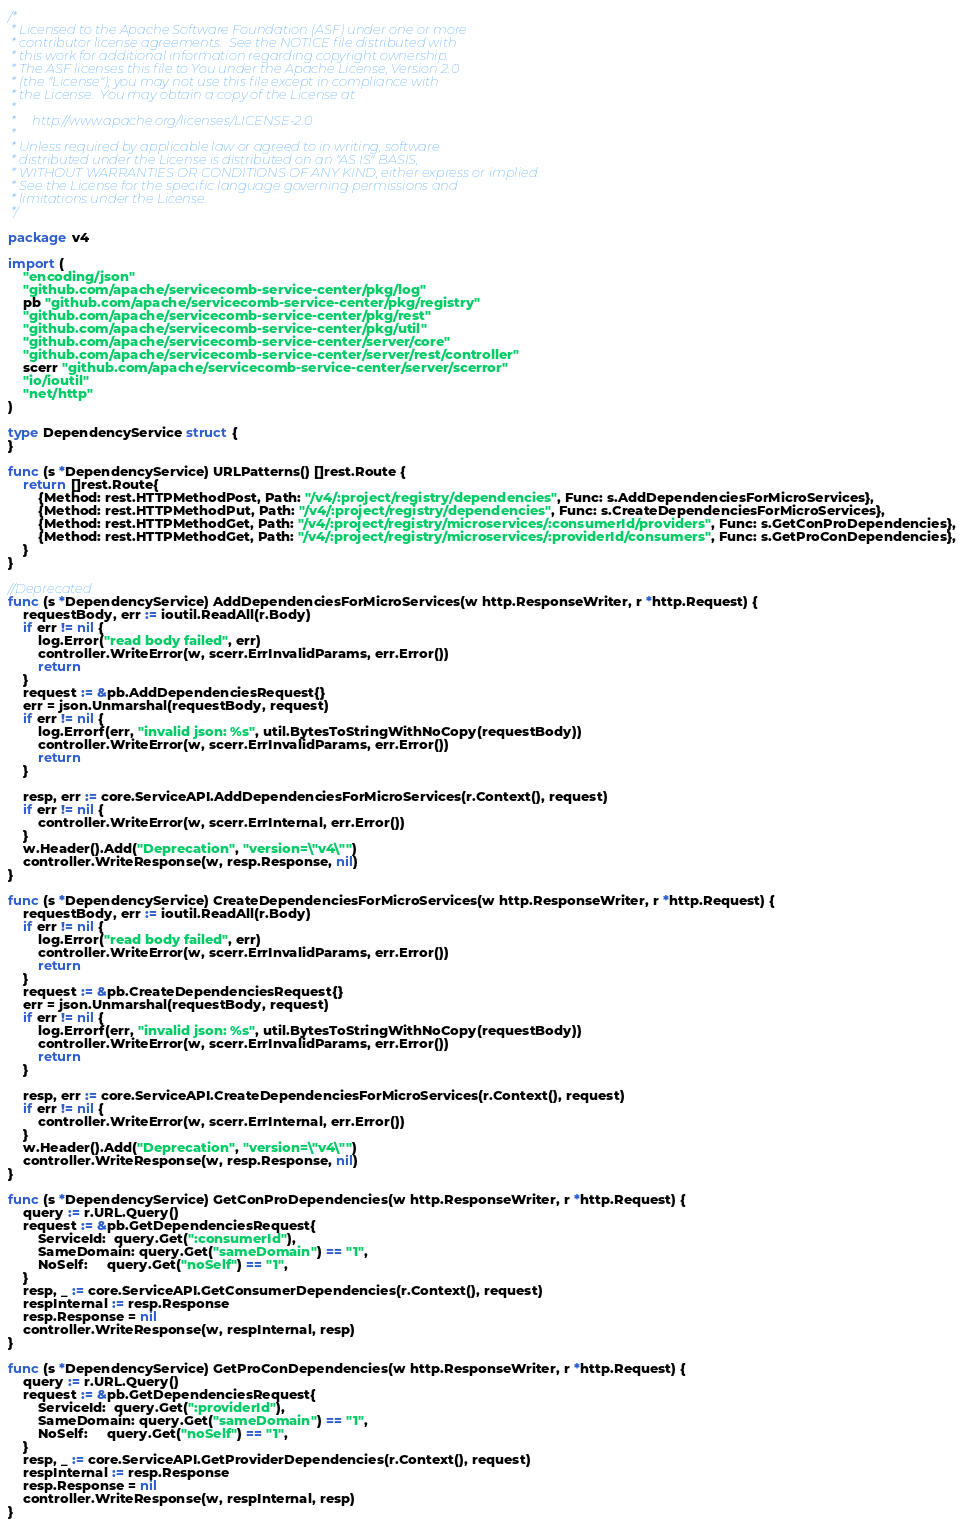Convert code to text. <code><loc_0><loc_0><loc_500><loc_500><_Go_>/*
 * Licensed to the Apache Software Foundation (ASF) under one or more
 * contributor license agreements.  See the NOTICE file distributed with
 * this work for additional information regarding copyright ownership.
 * The ASF licenses this file to You under the Apache License, Version 2.0
 * (the "License"); you may not use this file except in compliance with
 * the License.  You may obtain a copy of the License at
 *
 *     http://www.apache.org/licenses/LICENSE-2.0
 *
 * Unless required by applicable law or agreed to in writing, software
 * distributed under the License is distributed on an "AS IS" BASIS,
 * WITHOUT WARRANTIES OR CONDITIONS OF ANY KIND, either express or implied.
 * See the License for the specific language governing permissions and
 * limitations under the License.
 */

package v4

import (
	"encoding/json"
	"github.com/apache/servicecomb-service-center/pkg/log"
	pb "github.com/apache/servicecomb-service-center/pkg/registry"
	"github.com/apache/servicecomb-service-center/pkg/rest"
	"github.com/apache/servicecomb-service-center/pkg/util"
	"github.com/apache/servicecomb-service-center/server/core"
	"github.com/apache/servicecomb-service-center/server/rest/controller"
	scerr "github.com/apache/servicecomb-service-center/server/scerror"
	"io/ioutil"
	"net/http"
)

type DependencyService struct {
}

func (s *DependencyService) URLPatterns() []rest.Route {
	return []rest.Route{
		{Method: rest.HTTPMethodPost, Path: "/v4/:project/registry/dependencies", Func: s.AddDependenciesForMicroServices},
		{Method: rest.HTTPMethodPut, Path: "/v4/:project/registry/dependencies", Func: s.CreateDependenciesForMicroServices},
		{Method: rest.HTTPMethodGet, Path: "/v4/:project/registry/microservices/:consumerId/providers", Func: s.GetConProDependencies},
		{Method: rest.HTTPMethodGet, Path: "/v4/:project/registry/microservices/:providerId/consumers", Func: s.GetProConDependencies},
	}
}

//Deprecated
func (s *DependencyService) AddDependenciesForMicroServices(w http.ResponseWriter, r *http.Request) {
	requestBody, err := ioutil.ReadAll(r.Body)
	if err != nil {
		log.Error("read body failed", err)
		controller.WriteError(w, scerr.ErrInvalidParams, err.Error())
		return
	}
	request := &pb.AddDependenciesRequest{}
	err = json.Unmarshal(requestBody, request)
	if err != nil {
		log.Errorf(err, "invalid json: %s", util.BytesToStringWithNoCopy(requestBody))
		controller.WriteError(w, scerr.ErrInvalidParams, err.Error())
		return
	}

	resp, err := core.ServiceAPI.AddDependenciesForMicroServices(r.Context(), request)
	if err != nil {
		controller.WriteError(w, scerr.ErrInternal, err.Error())
	}
	w.Header().Add("Deprecation", "version=\"v4\"")
	controller.WriteResponse(w, resp.Response, nil)
}

func (s *DependencyService) CreateDependenciesForMicroServices(w http.ResponseWriter, r *http.Request) {
	requestBody, err := ioutil.ReadAll(r.Body)
	if err != nil {
		log.Error("read body failed", err)
		controller.WriteError(w, scerr.ErrInvalidParams, err.Error())
		return
	}
	request := &pb.CreateDependenciesRequest{}
	err = json.Unmarshal(requestBody, request)
	if err != nil {
		log.Errorf(err, "invalid json: %s", util.BytesToStringWithNoCopy(requestBody))
		controller.WriteError(w, scerr.ErrInvalidParams, err.Error())
		return
	}

	resp, err := core.ServiceAPI.CreateDependenciesForMicroServices(r.Context(), request)
	if err != nil {
		controller.WriteError(w, scerr.ErrInternal, err.Error())
	}
	w.Header().Add("Deprecation", "version=\"v4\"")
	controller.WriteResponse(w, resp.Response, nil)
}

func (s *DependencyService) GetConProDependencies(w http.ResponseWriter, r *http.Request) {
	query := r.URL.Query()
	request := &pb.GetDependenciesRequest{
		ServiceId:  query.Get(":consumerId"),
		SameDomain: query.Get("sameDomain") == "1",
		NoSelf:     query.Get("noSelf") == "1",
	}
	resp, _ := core.ServiceAPI.GetConsumerDependencies(r.Context(), request)
	respInternal := resp.Response
	resp.Response = nil
	controller.WriteResponse(w, respInternal, resp)
}

func (s *DependencyService) GetProConDependencies(w http.ResponseWriter, r *http.Request) {
	query := r.URL.Query()
	request := &pb.GetDependenciesRequest{
		ServiceId:  query.Get(":providerId"),
		SameDomain: query.Get("sameDomain") == "1",
		NoSelf:     query.Get("noSelf") == "1",
	}
	resp, _ := core.ServiceAPI.GetProviderDependencies(r.Context(), request)
	respInternal := resp.Response
	resp.Response = nil
	controller.WriteResponse(w, respInternal, resp)
}
</code> 